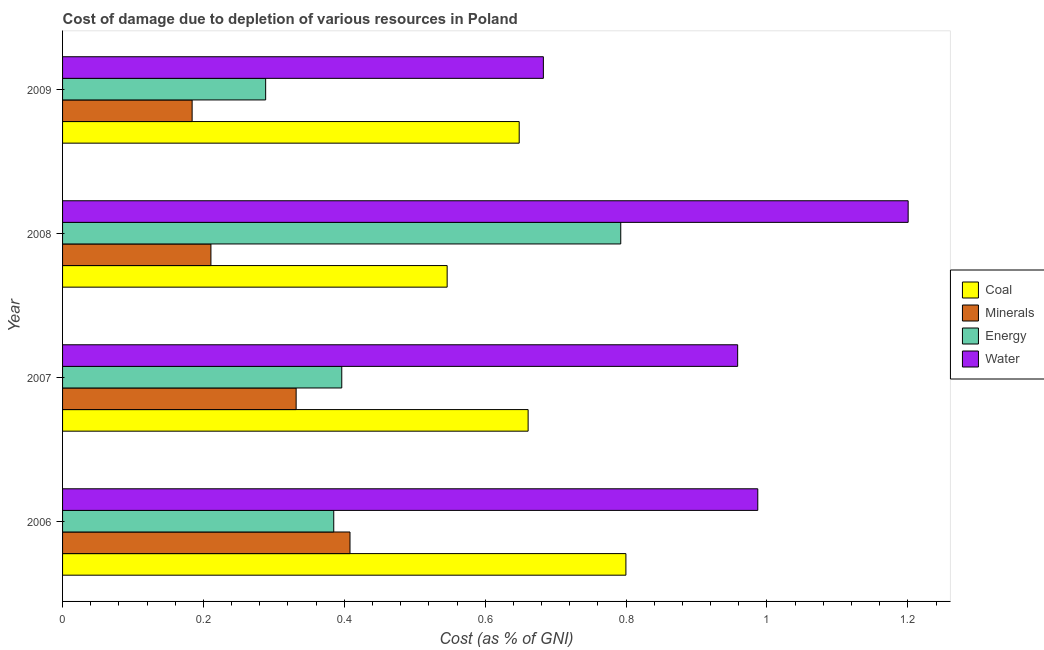Are the number of bars on each tick of the Y-axis equal?
Provide a succinct answer. Yes. How many bars are there on the 4th tick from the bottom?
Ensure brevity in your answer.  4. What is the label of the 4th group of bars from the top?
Ensure brevity in your answer.  2006. What is the cost of damage due to depletion of energy in 2008?
Your answer should be very brief. 0.79. Across all years, what is the maximum cost of damage due to depletion of energy?
Keep it short and to the point. 0.79. Across all years, what is the minimum cost of damage due to depletion of energy?
Provide a succinct answer. 0.29. In which year was the cost of damage due to depletion of coal maximum?
Ensure brevity in your answer.  2006. In which year was the cost of damage due to depletion of coal minimum?
Your answer should be compact. 2008. What is the total cost of damage due to depletion of minerals in the graph?
Your answer should be compact. 1.13. What is the difference between the cost of damage due to depletion of energy in 2007 and that in 2009?
Your response must be concise. 0.11. What is the difference between the cost of damage due to depletion of water in 2008 and the cost of damage due to depletion of coal in 2009?
Your response must be concise. 0.55. What is the average cost of damage due to depletion of coal per year?
Offer a terse response. 0.66. In the year 2009, what is the difference between the cost of damage due to depletion of minerals and cost of damage due to depletion of coal?
Give a very brief answer. -0.46. In how many years, is the cost of damage due to depletion of energy greater than 1.16 %?
Provide a succinct answer. 0. What is the ratio of the cost of damage due to depletion of water in 2006 to that in 2009?
Give a very brief answer. 1.45. Is the cost of damage due to depletion of minerals in 2007 less than that in 2008?
Offer a terse response. No. What is the difference between the highest and the second highest cost of damage due to depletion of minerals?
Offer a terse response. 0.08. Is the sum of the cost of damage due to depletion of water in 2006 and 2007 greater than the maximum cost of damage due to depletion of coal across all years?
Your answer should be compact. Yes. Is it the case that in every year, the sum of the cost of damage due to depletion of water and cost of damage due to depletion of minerals is greater than the sum of cost of damage due to depletion of coal and cost of damage due to depletion of energy?
Offer a very short reply. Yes. What does the 3rd bar from the top in 2006 represents?
Keep it short and to the point. Minerals. What does the 4th bar from the bottom in 2008 represents?
Give a very brief answer. Water. Is it the case that in every year, the sum of the cost of damage due to depletion of coal and cost of damage due to depletion of minerals is greater than the cost of damage due to depletion of energy?
Your response must be concise. No. How many bars are there?
Provide a short and direct response. 16. Are all the bars in the graph horizontal?
Your answer should be very brief. Yes. What is the difference between two consecutive major ticks on the X-axis?
Provide a short and direct response. 0.2. Are the values on the major ticks of X-axis written in scientific E-notation?
Provide a short and direct response. No. Does the graph contain any zero values?
Your answer should be very brief. No. Does the graph contain grids?
Provide a short and direct response. No. What is the title of the graph?
Make the answer very short. Cost of damage due to depletion of various resources in Poland . Does "International Monetary Fund" appear as one of the legend labels in the graph?
Give a very brief answer. No. What is the label or title of the X-axis?
Keep it short and to the point. Cost (as % of GNI). What is the Cost (as % of GNI) in Coal in 2006?
Your answer should be compact. 0.8. What is the Cost (as % of GNI) of Minerals in 2006?
Your answer should be compact. 0.41. What is the Cost (as % of GNI) in Energy in 2006?
Offer a very short reply. 0.38. What is the Cost (as % of GNI) of Water in 2006?
Offer a very short reply. 0.99. What is the Cost (as % of GNI) of Coal in 2007?
Your answer should be compact. 0.66. What is the Cost (as % of GNI) in Minerals in 2007?
Ensure brevity in your answer.  0.33. What is the Cost (as % of GNI) of Energy in 2007?
Make the answer very short. 0.4. What is the Cost (as % of GNI) of Water in 2007?
Provide a short and direct response. 0.96. What is the Cost (as % of GNI) of Coal in 2008?
Offer a very short reply. 0.55. What is the Cost (as % of GNI) in Minerals in 2008?
Your answer should be compact. 0.21. What is the Cost (as % of GNI) in Energy in 2008?
Offer a terse response. 0.79. What is the Cost (as % of GNI) in Water in 2008?
Offer a very short reply. 1.2. What is the Cost (as % of GNI) of Coal in 2009?
Give a very brief answer. 0.65. What is the Cost (as % of GNI) of Minerals in 2009?
Keep it short and to the point. 0.18. What is the Cost (as % of GNI) of Energy in 2009?
Your answer should be very brief. 0.29. What is the Cost (as % of GNI) in Water in 2009?
Your answer should be compact. 0.68. Across all years, what is the maximum Cost (as % of GNI) of Coal?
Provide a short and direct response. 0.8. Across all years, what is the maximum Cost (as % of GNI) in Minerals?
Give a very brief answer. 0.41. Across all years, what is the maximum Cost (as % of GNI) of Energy?
Your answer should be very brief. 0.79. Across all years, what is the maximum Cost (as % of GNI) in Water?
Your answer should be very brief. 1.2. Across all years, what is the minimum Cost (as % of GNI) in Coal?
Your answer should be very brief. 0.55. Across all years, what is the minimum Cost (as % of GNI) of Minerals?
Ensure brevity in your answer.  0.18. Across all years, what is the minimum Cost (as % of GNI) of Energy?
Your answer should be compact. 0.29. Across all years, what is the minimum Cost (as % of GNI) of Water?
Your answer should be very brief. 0.68. What is the total Cost (as % of GNI) in Coal in the graph?
Your answer should be very brief. 2.65. What is the total Cost (as % of GNI) of Minerals in the graph?
Your answer should be very brief. 1.13. What is the total Cost (as % of GNI) in Energy in the graph?
Your answer should be very brief. 1.86. What is the total Cost (as % of GNI) in Water in the graph?
Provide a short and direct response. 3.83. What is the difference between the Cost (as % of GNI) of Coal in 2006 and that in 2007?
Your answer should be compact. 0.14. What is the difference between the Cost (as % of GNI) of Minerals in 2006 and that in 2007?
Make the answer very short. 0.08. What is the difference between the Cost (as % of GNI) in Energy in 2006 and that in 2007?
Keep it short and to the point. -0.01. What is the difference between the Cost (as % of GNI) of Water in 2006 and that in 2007?
Your response must be concise. 0.03. What is the difference between the Cost (as % of GNI) in Coal in 2006 and that in 2008?
Your response must be concise. 0.25. What is the difference between the Cost (as % of GNI) of Minerals in 2006 and that in 2008?
Your answer should be very brief. 0.2. What is the difference between the Cost (as % of GNI) of Energy in 2006 and that in 2008?
Your answer should be compact. -0.41. What is the difference between the Cost (as % of GNI) of Water in 2006 and that in 2008?
Provide a short and direct response. -0.21. What is the difference between the Cost (as % of GNI) in Coal in 2006 and that in 2009?
Provide a succinct answer. 0.15. What is the difference between the Cost (as % of GNI) of Minerals in 2006 and that in 2009?
Your response must be concise. 0.22. What is the difference between the Cost (as % of GNI) in Energy in 2006 and that in 2009?
Give a very brief answer. 0.1. What is the difference between the Cost (as % of GNI) in Water in 2006 and that in 2009?
Provide a short and direct response. 0.3. What is the difference between the Cost (as % of GNI) of Coal in 2007 and that in 2008?
Your answer should be very brief. 0.11. What is the difference between the Cost (as % of GNI) of Minerals in 2007 and that in 2008?
Give a very brief answer. 0.12. What is the difference between the Cost (as % of GNI) of Energy in 2007 and that in 2008?
Ensure brevity in your answer.  -0.4. What is the difference between the Cost (as % of GNI) in Water in 2007 and that in 2008?
Offer a terse response. -0.24. What is the difference between the Cost (as % of GNI) of Coal in 2007 and that in 2009?
Provide a succinct answer. 0.01. What is the difference between the Cost (as % of GNI) in Minerals in 2007 and that in 2009?
Keep it short and to the point. 0.15. What is the difference between the Cost (as % of GNI) in Energy in 2007 and that in 2009?
Ensure brevity in your answer.  0.11. What is the difference between the Cost (as % of GNI) of Water in 2007 and that in 2009?
Your answer should be very brief. 0.28. What is the difference between the Cost (as % of GNI) of Coal in 2008 and that in 2009?
Your response must be concise. -0.1. What is the difference between the Cost (as % of GNI) in Minerals in 2008 and that in 2009?
Offer a very short reply. 0.03. What is the difference between the Cost (as % of GNI) of Energy in 2008 and that in 2009?
Offer a terse response. 0.5. What is the difference between the Cost (as % of GNI) in Water in 2008 and that in 2009?
Keep it short and to the point. 0.52. What is the difference between the Cost (as % of GNI) in Coal in 2006 and the Cost (as % of GNI) in Minerals in 2007?
Keep it short and to the point. 0.47. What is the difference between the Cost (as % of GNI) of Coal in 2006 and the Cost (as % of GNI) of Energy in 2007?
Offer a very short reply. 0.4. What is the difference between the Cost (as % of GNI) of Coal in 2006 and the Cost (as % of GNI) of Water in 2007?
Provide a succinct answer. -0.16. What is the difference between the Cost (as % of GNI) in Minerals in 2006 and the Cost (as % of GNI) in Energy in 2007?
Provide a succinct answer. 0.01. What is the difference between the Cost (as % of GNI) in Minerals in 2006 and the Cost (as % of GNI) in Water in 2007?
Give a very brief answer. -0.55. What is the difference between the Cost (as % of GNI) in Energy in 2006 and the Cost (as % of GNI) in Water in 2007?
Your answer should be compact. -0.57. What is the difference between the Cost (as % of GNI) of Coal in 2006 and the Cost (as % of GNI) of Minerals in 2008?
Offer a very short reply. 0.59. What is the difference between the Cost (as % of GNI) in Coal in 2006 and the Cost (as % of GNI) in Energy in 2008?
Provide a short and direct response. 0.01. What is the difference between the Cost (as % of GNI) of Coal in 2006 and the Cost (as % of GNI) of Water in 2008?
Provide a short and direct response. -0.4. What is the difference between the Cost (as % of GNI) in Minerals in 2006 and the Cost (as % of GNI) in Energy in 2008?
Provide a short and direct response. -0.38. What is the difference between the Cost (as % of GNI) in Minerals in 2006 and the Cost (as % of GNI) in Water in 2008?
Give a very brief answer. -0.79. What is the difference between the Cost (as % of GNI) in Energy in 2006 and the Cost (as % of GNI) in Water in 2008?
Your response must be concise. -0.82. What is the difference between the Cost (as % of GNI) in Coal in 2006 and the Cost (as % of GNI) in Minerals in 2009?
Your answer should be very brief. 0.62. What is the difference between the Cost (as % of GNI) of Coal in 2006 and the Cost (as % of GNI) of Energy in 2009?
Give a very brief answer. 0.51. What is the difference between the Cost (as % of GNI) in Coal in 2006 and the Cost (as % of GNI) in Water in 2009?
Offer a very short reply. 0.12. What is the difference between the Cost (as % of GNI) in Minerals in 2006 and the Cost (as % of GNI) in Energy in 2009?
Provide a short and direct response. 0.12. What is the difference between the Cost (as % of GNI) of Minerals in 2006 and the Cost (as % of GNI) of Water in 2009?
Keep it short and to the point. -0.27. What is the difference between the Cost (as % of GNI) in Energy in 2006 and the Cost (as % of GNI) in Water in 2009?
Provide a short and direct response. -0.3. What is the difference between the Cost (as % of GNI) in Coal in 2007 and the Cost (as % of GNI) in Minerals in 2008?
Keep it short and to the point. 0.45. What is the difference between the Cost (as % of GNI) of Coal in 2007 and the Cost (as % of GNI) of Energy in 2008?
Your answer should be very brief. -0.13. What is the difference between the Cost (as % of GNI) in Coal in 2007 and the Cost (as % of GNI) in Water in 2008?
Your answer should be compact. -0.54. What is the difference between the Cost (as % of GNI) of Minerals in 2007 and the Cost (as % of GNI) of Energy in 2008?
Provide a succinct answer. -0.46. What is the difference between the Cost (as % of GNI) of Minerals in 2007 and the Cost (as % of GNI) of Water in 2008?
Provide a succinct answer. -0.87. What is the difference between the Cost (as % of GNI) in Energy in 2007 and the Cost (as % of GNI) in Water in 2008?
Your answer should be compact. -0.8. What is the difference between the Cost (as % of GNI) of Coal in 2007 and the Cost (as % of GNI) of Minerals in 2009?
Keep it short and to the point. 0.48. What is the difference between the Cost (as % of GNI) in Coal in 2007 and the Cost (as % of GNI) in Energy in 2009?
Your response must be concise. 0.37. What is the difference between the Cost (as % of GNI) of Coal in 2007 and the Cost (as % of GNI) of Water in 2009?
Provide a succinct answer. -0.02. What is the difference between the Cost (as % of GNI) in Minerals in 2007 and the Cost (as % of GNI) in Energy in 2009?
Keep it short and to the point. 0.04. What is the difference between the Cost (as % of GNI) in Minerals in 2007 and the Cost (as % of GNI) in Water in 2009?
Your response must be concise. -0.35. What is the difference between the Cost (as % of GNI) of Energy in 2007 and the Cost (as % of GNI) of Water in 2009?
Offer a very short reply. -0.29. What is the difference between the Cost (as % of GNI) in Coal in 2008 and the Cost (as % of GNI) in Minerals in 2009?
Keep it short and to the point. 0.36. What is the difference between the Cost (as % of GNI) of Coal in 2008 and the Cost (as % of GNI) of Energy in 2009?
Give a very brief answer. 0.26. What is the difference between the Cost (as % of GNI) of Coal in 2008 and the Cost (as % of GNI) of Water in 2009?
Provide a short and direct response. -0.14. What is the difference between the Cost (as % of GNI) in Minerals in 2008 and the Cost (as % of GNI) in Energy in 2009?
Give a very brief answer. -0.08. What is the difference between the Cost (as % of GNI) in Minerals in 2008 and the Cost (as % of GNI) in Water in 2009?
Your answer should be compact. -0.47. What is the difference between the Cost (as % of GNI) in Energy in 2008 and the Cost (as % of GNI) in Water in 2009?
Provide a short and direct response. 0.11. What is the average Cost (as % of GNI) in Coal per year?
Give a very brief answer. 0.66. What is the average Cost (as % of GNI) in Minerals per year?
Offer a very short reply. 0.28. What is the average Cost (as % of GNI) in Energy per year?
Ensure brevity in your answer.  0.47. What is the average Cost (as % of GNI) in Water per year?
Offer a very short reply. 0.96. In the year 2006, what is the difference between the Cost (as % of GNI) of Coal and Cost (as % of GNI) of Minerals?
Provide a succinct answer. 0.39. In the year 2006, what is the difference between the Cost (as % of GNI) in Coal and Cost (as % of GNI) in Energy?
Your answer should be compact. 0.41. In the year 2006, what is the difference between the Cost (as % of GNI) of Coal and Cost (as % of GNI) of Water?
Make the answer very short. -0.19. In the year 2006, what is the difference between the Cost (as % of GNI) of Minerals and Cost (as % of GNI) of Energy?
Your answer should be very brief. 0.02. In the year 2006, what is the difference between the Cost (as % of GNI) of Minerals and Cost (as % of GNI) of Water?
Ensure brevity in your answer.  -0.58. In the year 2006, what is the difference between the Cost (as % of GNI) in Energy and Cost (as % of GNI) in Water?
Provide a short and direct response. -0.6. In the year 2007, what is the difference between the Cost (as % of GNI) of Coal and Cost (as % of GNI) of Minerals?
Provide a succinct answer. 0.33. In the year 2007, what is the difference between the Cost (as % of GNI) in Coal and Cost (as % of GNI) in Energy?
Provide a short and direct response. 0.26. In the year 2007, what is the difference between the Cost (as % of GNI) of Coal and Cost (as % of GNI) of Water?
Ensure brevity in your answer.  -0.3. In the year 2007, what is the difference between the Cost (as % of GNI) in Minerals and Cost (as % of GNI) in Energy?
Offer a very short reply. -0.06. In the year 2007, what is the difference between the Cost (as % of GNI) in Minerals and Cost (as % of GNI) in Water?
Provide a short and direct response. -0.63. In the year 2007, what is the difference between the Cost (as % of GNI) of Energy and Cost (as % of GNI) of Water?
Your answer should be very brief. -0.56. In the year 2008, what is the difference between the Cost (as % of GNI) of Coal and Cost (as % of GNI) of Minerals?
Your answer should be compact. 0.34. In the year 2008, what is the difference between the Cost (as % of GNI) in Coal and Cost (as % of GNI) in Energy?
Make the answer very short. -0.25. In the year 2008, what is the difference between the Cost (as % of GNI) in Coal and Cost (as % of GNI) in Water?
Make the answer very short. -0.65. In the year 2008, what is the difference between the Cost (as % of GNI) of Minerals and Cost (as % of GNI) of Energy?
Keep it short and to the point. -0.58. In the year 2008, what is the difference between the Cost (as % of GNI) of Minerals and Cost (as % of GNI) of Water?
Offer a very short reply. -0.99. In the year 2008, what is the difference between the Cost (as % of GNI) of Energy and Cost (as % of GNI) of Water?
Your answer should be very brief. -0.41. In the year 2009, what is the difference between the Cost (as % of GNI) of Coal and Cost (as % of GNI) of Minerals?
Ensure brevity in your answer.  0.46. In the year 2009, what is the difference between the Cost (as % of GNI) of Coal and Cost (as % of GNI) of Energy?
Make the answer very short. 0.36. In the year 2009, what is the difference between the Cost (as % of GNI) in Coal and Cost (as % of GNI) in Water?
Make the answer very short. -0.03. In the year 2009, what is the difference between the Cost (as % of GNI) in Minerals and Cost (as % of GNI) in Energy?
Offer a terse response. -0.1. In the year 2009, what is the difference between the Cost (as % of GNI) in Minerals and Cost (as % of GNI) in Water?
Provide a short and direct response. -0.5. In the year 2009, what is the difference between the Cost (as % of GNI) of Energy and Cost (as % of GNI) of Water?
Keep it short and to the point. -0.39. What is the ratio of the Cost (as % of GNI) of Coal in 2006 to that in 2007?
Your answer should be compact. 1.21. What is the ratio of the Cost (as % of GNI) of Minerals in 2006 to that in 2007?
Offer a very short reply. 1.23. What is the ratio of the Cost (as % of GNI) of Energy in 2006 to that in 2007?
Provide a succinct answer. 0.97. What is the ratio of the Cost (as % of GNI) in Water in 2006 to that in 2007?
Your answer should be compact. 1.03. What is the ratio of the Cost (as % of GNI) of Coal in 2006 to that in 2008?
Ensure brevity in your answer.  1.46. What is the ratio of the Cost (as % of GNI) in Minerals in 2006 to that in 2008?
Keep it short and to the point. 1.94. What is the ratio of the Cost (as % of GNI) in Energy in 2006 to that in 2008?
Provide a short and direct response. 0.49. What is the ratio of the Cost (as % of GNI) in Water in 2006 to that in 2008?
Give a very brief answer. 0.82. What is the ratio of the Cost (as % of GNI) of Coal in 2006 to that in 2009?
Your response must be concise. 1.23. What is the ratio of the Cost (as % of GNI) in Minerals in 2006 to that in 2009?
Offer a terse response. 2.22. What is the ratio of the Cost (as % of GNI) in Energy in 2006 to that in 2009?
Provide a short and direct response. 1.34. What is the ratio of the Cost (as % of GNI) of Water in 2006 to that in 2009?
Your answer should be compact. 1.45. What is the ratio of the Cost (as % of GNI) in Coal in 2007 to that in 2008?
Your answer should be very brief. 1.21. What is the ratio of the Cost (as % of GNI) of Minerals in 2007 to that in 2008?
Provide a succinct answer. 1.57. What is the ratio of the Cost (as % of GNI) of Energy in 2007 to that in 2008?
Make the answer very short. 0.5. What is the ratio of the Cost (as % of GNI) in Water in 2007 to that in 2008?
Offer a very short reply. 0.8. What is the ratio of the Cost (as % of GNI) in Coal in 2007 to that in 2009?
Provide a succinct answer. 1.02. What is the ratio of the Cost (as % of GNI) in Minerals in 2007 to that in 2009?
Keep it short and to the point. 1.8. What is the ratio of the Cost (as % of GNI) of Energy in 2007 to that in 2009?
Provide a succinct answer. 1.37. What is the ratio of the Cost (as % of GNI) of Water in 2007 to that in 2009?
Offer a very short reply. 1.4. What is the ratio of the Cost (as % of GNI) in Coal in 2008 to that in 2009?
Keep it short and to the point. 0.84. What is the ratio of the Cost (as % of GNI) of Minerals in 2008 to that in 2009?
Make the answer very short. 1.15. What is the ratio of the Cost (as % of GNI) of Energy in 2008 to that in 2009?
Offer a terse response. 2.75. What is the ratio of the Cost (as % of GNI) in Water in 2008 to that in 2009?
Offer a terse response. 1.76. What is the difference between the highest and the second highest Cost (as % of GNI) in Coal?
Offer a very short reply. 0.14. What is the difference between the highest and the second highest Cost (as % of GNI) in Minerals?
Offer a terse response. 0.08. What is the difference between the highest and the second highest Cost (as % of GNI) of Energy?
Offer a terse response. 0.4. What is the difference between the highest and the second highest Cost (as % of GNI) in Water?
Provide a succinct answer. 0.21. What is the difference between the highest and the lowest Cost (as % of GNI) of Coal?
Your answer should be very brief. 0.25. What is the difference between the highest and the lowest Cost (as % of GNI) of Minerals?
Give a very brief answer. 0.22. What is the difference between the highest and the lowest Cost (as % of GNI) in Energy?
Your answer should be very brief. 0.5. What is the difference between the highest and the lowest Cost (as % of GNI) of Water?
Your answer should be compact. 0.52. 